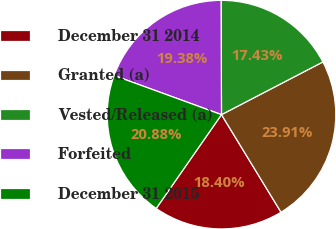Convert chart to OTSL. <chart><loc_0><loc_0><loc_500><loc_500><pie_chart><fcel>December 31 2014<fcel>Granted (a)<fcel>Vested/Released (a)<fcel>Forfeited<fcel>December 31 2015<nl><fcel>18.4%<fcel>23.91%<fcel>17.43%<fcel>19.38%<fcel>20.88%<nl></chart> 